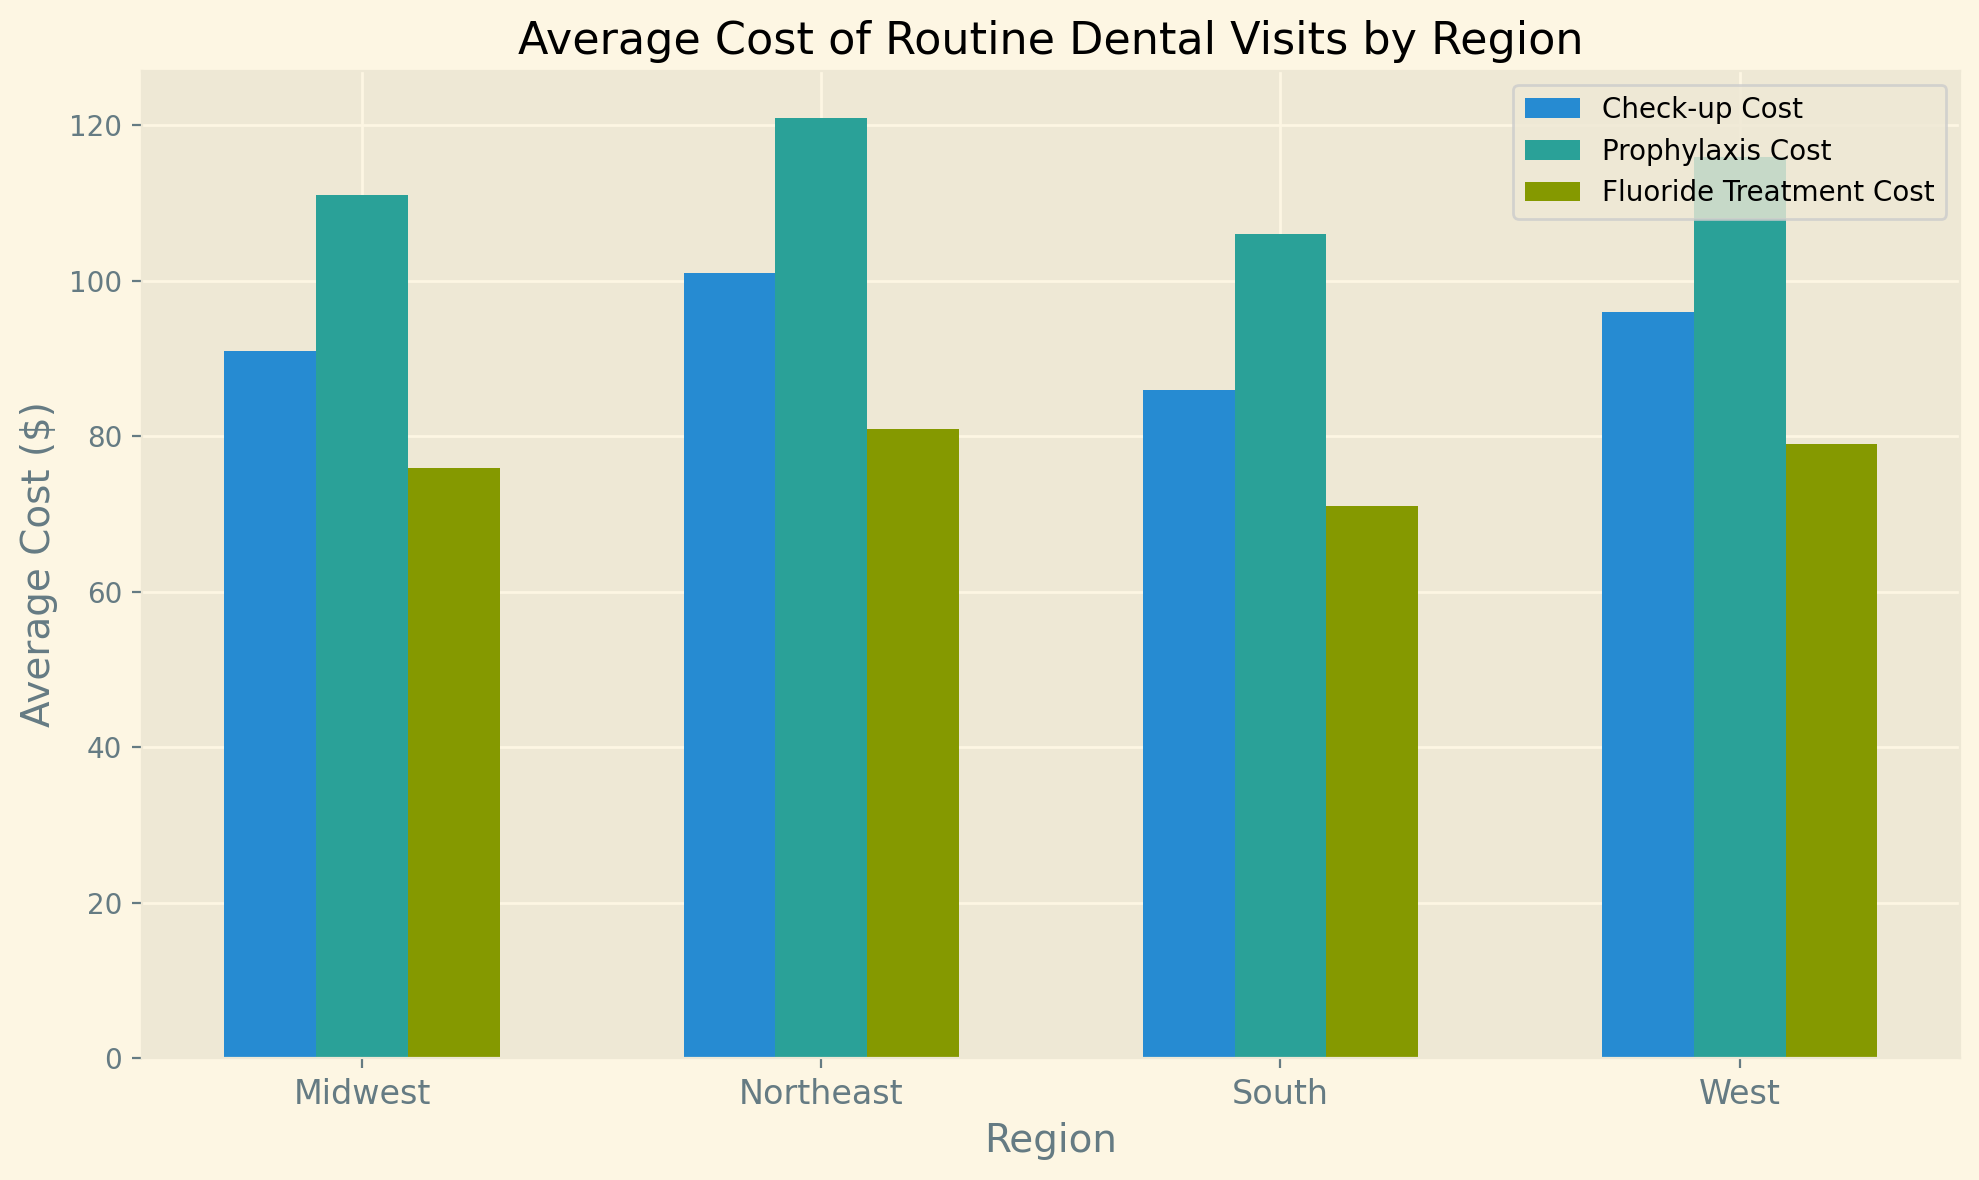What is the average check-up cost for the Midwest region? To find the average check-up cost for the Midwest, look at the bar representing the "Check-up Cost" in the Midwest group and note its height. The data table provided shows the average value for the Midwest region as 91.
Answer: 91 Which region has the highest average cost for prophylaxis? Compare the heights of the bars labeled "Prophylaxis Cost" across all regions. Identify the tallest bar to determine the region with the highest average cost. The Northeast has the highest value of 121.
Answer: Northeast How does the average fluoride treatment cost in the West compare to the Northeast? Look at the heights of the "Fluoride Treatment Cost" bars for both the West and Northeast regions. The average fluoride treatment cost in the Northeast is 81, while in the West it is 79.
Answer: The Northeast is higher What is the difference between the average check-up cost in the South and West regions? Refer to the heights of the bars representing "Check-up Cost" for both the South and West. Subtract the lower value (South = 86) from the higher value (West = 96). The difference is 96 - 86 = 10.
Answer: 10 Among all the regions, which has the lowest average fluoride treatment cost and what is the value? Compare the heights of all the bars representing "Fluoride Treatment Cost" across regions. The South has the lowest bar at 71.
Answer: South, 71 What is the sum of the average prophylaxis costs for the Midwest and South regions? Add the average "Prophylaxis Cost" values for the Midwest (111) and South (106). The sum is 111 + 106 = 217.
Answer: 217 Which region shows a higher average cost for check-ups than the Midwest but lower than the Northeast? Compare the average "Check-up Cost" bars for all regions. The Midwest is 91, the Northeast is 101, and the West has a value of 96 that falls between these.
Answer: West What is the average cost of all the procedures (check-up, prophylaxis, and fluoride treatment) in the Northeast? To get the average cost of all procedures in the Northeast, sum the values for the region: Check-up = 101, Prophylaxis = 121, Fluoride Treatment = 81. Calculate the overall average: (101 + 121 + 81) / 3 = 101.
Answer: 101 By how much does the average fluoride treatment cost in the Midwest surpass that in the South? Subtract the average "Fluoride Treatment Cost" for the South (71) from the Midwest (76). The difference is 76 - 71 = 5.
Answer: 5 Does any region show equal average costs for any two types of procedures? Visually compare the bar heights within each region to determine if any two bars are equal. None of the regions have any equal values for any two procedures.
Answer: No 